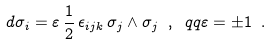<formula> <loc_0><loc_0><loc_500><loc_500>d \sigma _ { i } = \varepsilon \, \frac { 1 } { 2 } \, \epsilon _ { i j k } \, \sigma _ { j } \wedge \sigma _ { j } \ , \ q q \varepsilon = \pm 1 \ .</formula> 